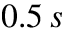<formula> <loc_0><loc_0><loc_500><loc_500>0 . 5 \, s</formula> 